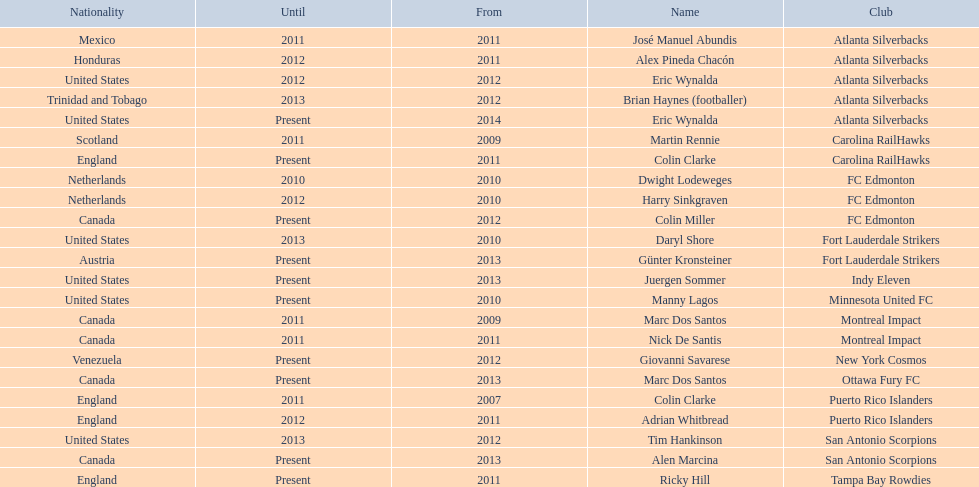What year did marc dos santos start as coach? 2009. Which other starting years correspond with this year? 2009. Who was the other coach with this starting year Martin Rennie. 